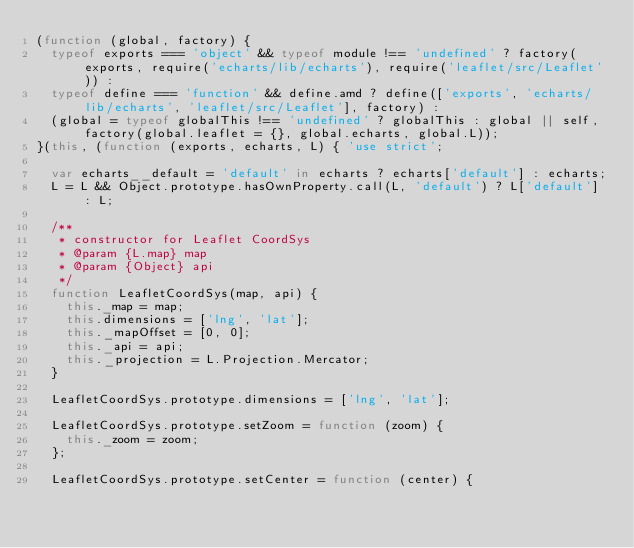<code> <loc_0><loc_0><loc_500><loc_500><_JavaScript_>(function (global, factory) {
  typeof exports === 'object' && typeof module !== 'undefined' ? factory(exports, require('echarts/lib/echarts'), require('leaflet/src/Leaflet')) :
  typeof define === 'function' && define.amd ? define(['exports', 'echarts/lib/echarts', 'leaflet/src/Leaflet'], factory) :
  (global = typeof globalThis !== 'undefined' ? globalThis : global || self, factory(global.leaflet = {}, global.echarts, global.L));
}(this, (function (exports, echarts, L) { 'use strict';

  var echarts__default = 'default' in echarts ? echarts['default'] : echarts;
  L = L && Object.prototype.hasOwnProperty.call(L, 'default') ? L['default'] : L;

  /**
   * constructor for Leaflet CoordSys
   * @param {L.map} map
   * @param {Object} api
   */
  function LeafletCoordSys(map, api) {
    this._map = map;
    this.dimensions = ['lng', 'lat'];
    this._mapOffset = [0, 0];
    this._api = api;
    this._projection = L.Projection.Mercator;
  }

  LeafletCoordSys.prototype.dimensions = ['lng', 'lat'];

  LeafletCoordSys.prototype.setZoom = function (zoom) {
    this._zoom = zoom;
  };

  LeafletCoordSys.prototype.setCenter = function (center) {</code> 